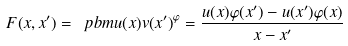Convert formula to latex. <formula><loc_0><loc_0><loc_500><loc_500>F ( x , x ^ { \prime } ) = \ p b m { u ( x ) } { v ( x ^ { \prime } ) } ^ { \varphi } = \frac { u ( x ) \varphi ( x ^ { \prime } ) - u ( x ^ { \prime } ) \varphi ( x ) } { x - x ^ { \prime } }</formula> 